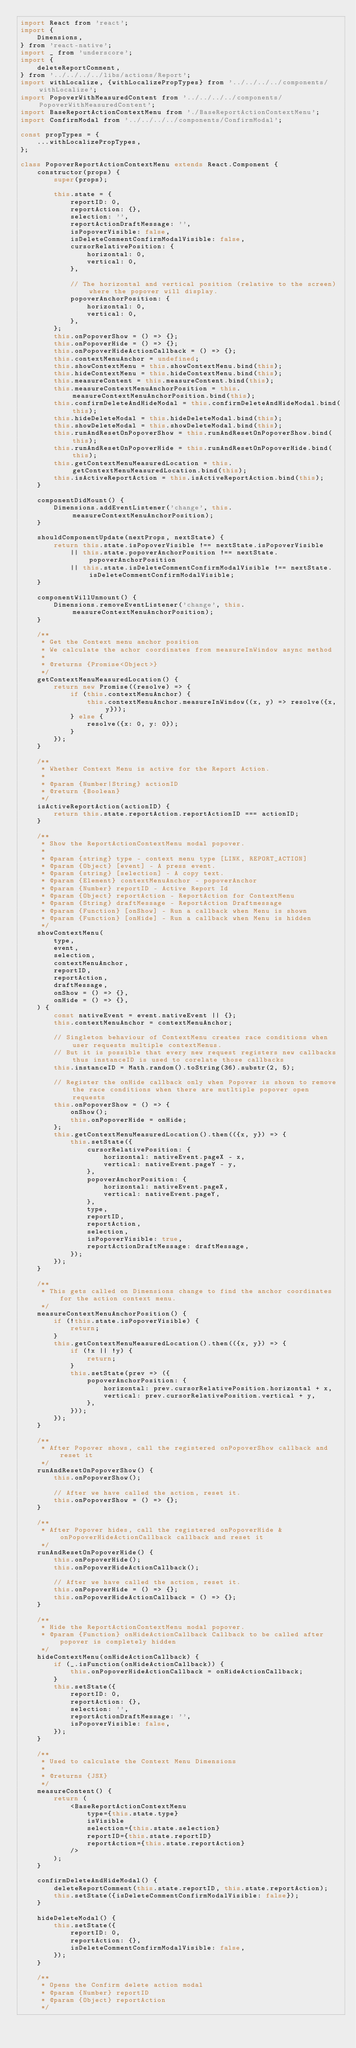Convert code to text. <code><loc_0><loc_0><loc_500><loc_500><_JavaScript_>import React from 'react';
import {
    Dimensions,
} from 'react-native';
import _ from 'underscore';
import {
    deleteReportComment,
} from '../../../../libs/actions/Report';
import withLocalize, {withLocalizePropTypes} from '../../../../components/withLocalize';
import PopoverWithMeasuredContent from '../../../../components/PopoverWithMeasuredContent';
import BaseReportActionContextMenu from './BaseReportActionContextMenu';
import ConfirmModal from '../../../../components/ConfirmModal';

const propTypes = {
    ...withLocalizePropTypes,
};

class PopoverReportActionContextMenu extends React.Component {
    constructor(props) {
        super(props);

        this.state = {
            reportID: 0,
            reportAction: {},
            selection: '',
            reportActionDraftMessage: '',
            isPopoverVisible: false,
            isDeleteCommentConfirmModalVisible: false,
            cursorRelativePosition: {
                horizontal: 0,
                vertical: 0,
            },

            // The horizontal and vertical position (relative to the screen) where the popover will display.
            popoverAnchorPosition: {
                horizontal: 0,
                vertical: 0,
            },
        };
        this.onPopoverShow = () => {};
        this.onPopoverHide = () => {};
        this.onPopoverHideActionCallback = () => {};
        this.contextMenuAnchor = undefined;
        this.showContextMenu = this.showContextMenu.bind(this);
        this.hideContextMenu = this.hideContextMenu.bind(this);
        this.measureContent = this.measureContent.bind(this);
        this.measureContextMenuAnchorPosition = this.measureContextMenuAnchorPosition.bind(this);
        this.confirmDeleteAndHideModal = this.confirmDeleteAndHideModal.bind(this);
        this.hideDeleteModal = this.hideDeleteModal.bind(this);
        this.showDeleteModal = this.showDeleteModal.bind(this);
        this.runAndResetOnPopoverShow = this.runAndResetOnPopoverShow.bind(this);
        this.runAndResetOnPopoverHide = this.runAndResetOnPopoverHide.bind(this);
        this.getContextMenuMeasuredLocation = this.getContextMenuMeasuredLocation.bind(this);
        this.isActiveReportAction = this.isActiveReportAction.bind(this);
    }

    componentDidMount() {
        Dimensions.addEventListener('change', this.measureContextMenuAnchorPosition);
    }

    shouldComponentUpdate(nextProps, nextState) {
        return this.state.isPopoverVisible !== nextState.isPopoverVisible
            || this.state.popoverAnchorPosition !== nextState.popoverAnchorPosition
            || this.state.isDeleteCommentConfirmModalVisible !== nextState.isDeleteCommentConfirmModalVisible;
    }

    componentWillUnmount() {
        Dimensions.removeEventListener('change', this.measureContextMenuAnchorPosition);
    }

    /**
     * Get the Context menu anchor position
     * We calculate the achor coordinates from measureInWindow async method
     *
     * @returns {Promise<Object>}
     */
    getContextMenuMeasuredLocation() {
        return new Promise((resolve) => {
            if (this.contextMenuAnchor) {
                this.contextMenuAnchor.measureInWindow((x, y) => resolve({x, y}));
            } else {
                resolve({x: 0, y: 0});
            }
        });
    }

    /**
     * Whether Context Menu is active for the Report Action.
     *
     * @param {Number|String} actionID
     * @return {Boolean}
     */
    isActiveReportAction(actionID) {
        return this.state.reportAction.reportActionID === actionID;
    }

    /**
     * Show the ReportActionContextMenu modal popover.
     *
     * @param {string} type - context menu type [LINK, REPORT_ACTION]
     * @param {Object} [event] - A press event.
     * @param {string} [selection] - A copy text.
     * @param {Element} contextMenuAnchor - popoverAnchor
     * @param {Number} reportID - Active Report Id
     * @param {Object} reportAction - ReportAction for ContextMenu
     * @param {String} draftMessage - ReportAction Draftmessage
     * @param {Function} [onShow] - Run a callback when Menu is shown
     * @param {Function} [onHide] - Run a callback when Menu is hidden
     */
    showContextMenu(
        type,
        event,
        selection,
        contextMenuAnchor,
        reportID,
        reportAction,
        draftMessage,
        onShow = () => {},
        onHide = () => {},
    ) {
        const nativeEvent = event.nativeEvent || {};
        this.contextMenuAnchor = contextMenuAnchor;

        // Singleton behaviour of ContextMenu creates race conditions when user requests multiple contextMenus.
        // But it is possible that every new request registers new callbacks thus instanceID is used to corelate those callbacks
        this.instanceID = Math.random().toString(36).substr(2, 5);

        // Register the onHide callback only when Popover is shown to remove the race conditions when there are mutltiple popover open requests
        this.onPopoverShow = () => {
            onShow();
            this.onPopoverHide = onHide;
        };
        this.getContextMenuMeasuredLocation().then(({x, y}) => {
            this.setState({
                cursorRelativePosition: {
                    horizontal: nativeEvent.pageX - x,
                    vertical: nativeEvent.pageY - y,
                },
                popoverAnchorPosition: {
                    horizontal: nativeEvent.pageX,
                    vertical: nativeEvent.pageY,
                },
                type,
                reportID,
                reportAction,
                selection,
                isPopoverVisible: true,
                reportActionDraftMessage: draftMessage,
            });
        });
    }

    /**
     * This gets called on Dimensions change to find the anchor coordinates for the action context menu.
     */
    measureContextMenuAnchorPosition() {
        if (!this.state.isPopoverVisible) {
            return;
        }
        this.getContextMenuMeasuredLocation().then(({x, y}) => {
            if (!x || !y) {
                return;
            }
            this.setState(prev => ({
                popoverAnchorPosition: {
                    horizontal: prev.cursorRelativePosition.horizontal + x,
                    vertical: prev.cursorRelativePosition.vertical + y,
                },
            }));
        });
    }

    /**
     * After Popover shows, call the registered onPopoverShow callback and reset it
     */
    runAndResetOnPopoverShow() {
        this.onPopoverShow();

        // After we have called the action, reset it.
        this.onPopoverShow = () => {};
    }

    /**
     * After Popover hides, call the registered onPopoverHide & onPopoverHideActionCallback callback and reset it
     */
    runAndResetOnPopoverHide() {
        this.onPopoverHide();
        this.onPopoverHideActionCallback();

        // After we have called the action, reset it.
        this.onPopoverHide = () => {};
        this.onPopoverHideActionCallback = () => {};
    }

    /**
     * Hide the ReportActionContextMenu modal popover.
     * @param {Function} onHideActionCallback Callback to be called after popover is completely hidden
     */
    hideContextMenu(onHideActionCallback) {
        if (_.isFunction(onHideActionCallback)) {
            this.onPopoverHideActionCallback = onHideActionCallback;
        }
        this.setState({
            reportID: 0,
            reportAction: {},
            selection: '',
            reportActionDraftMessage: '',
            isPopoverVisible: false,
        });
    }

    /**
     * Used to calculate the Context Menu Dimensions
     *
     * @returns {JSX}
     */
    measureContent() {
        return (
            <BaseReportActionContextMenu
                type={this.state.type}
                isVisible
                selection={this.state.selection}
                reportID={this.state.reportID}
                reportAction={this.state.reportAction}
            />
        );
    }

    confirmDeleteAndHideModal() {
        deleteReportComment(this.state.reportID, this.state.reportAction);
        this.setState({isDeleteCommentConfirmModalVisible: false});
    }

    hideDeleteModal() {
        this.setState({
            reportID: 0,
            reportAction: {},
            isDeleteCommentConfirmModalVisible: false,
        });
    }

    /**
     * Opens the Confirm delete action modal
     * @param {Number} reportID
     * @param {Object} reportAction
     */</code> 